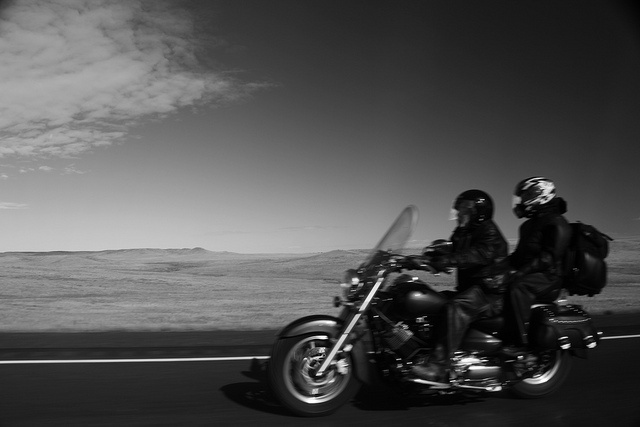Describe the objects in this image and their specific colors. I can see motorcycle in black, gray, darkgray, and lightgray tones, people in black, gray, and lightgray tones, people in black, gray, darkgray, and lightgray tones, and backpack in black and gray tones in this image. 